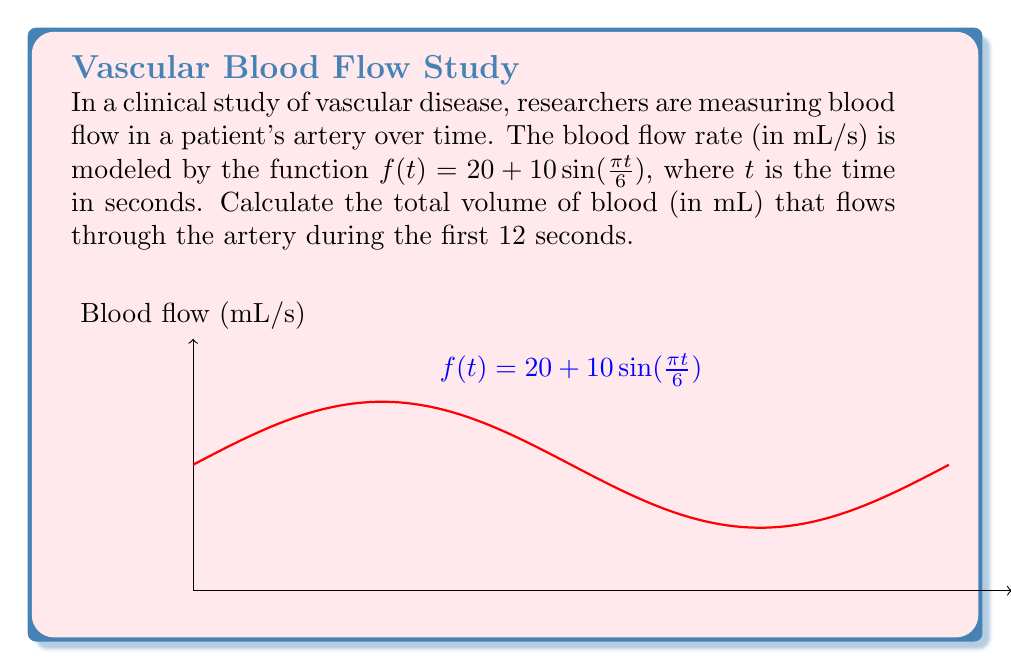Give your solution to this math problem. To find the total volume of blood that flows through the artery, we need to calculate the area under the curve of the blood flow rate function over the given time interval. This can be done using definite integration.

1) The function representing blood flow rate is:
   $f(t) = 20 + 10\sin(\frac{\pi t}{6})$

2) We need to integrate this function from $t=0$ to $t=12$:
   $\int_0^{12} (20 + 10\sin(\frac{\pi t}{6})) dt$

3) Let's separate the integral:
   $\int_0^{12} 20 dt + \int_0^{12} 10\sin(\frac{\pi t}{6}) dt$

4) Evaluate the first part:
   $20t|_0^{12} = 20 \cdot 12 - 20 \cdot 0 = 240$

5) For the second part, we use the substitution method:
   Let $u = \frac{\pi t}{6}$, then $du = \frac{\pi}{6}dt$ or $dt = \frac{6}{\pi}du$
   When $t=0$, $u=0$; when $t=12$, $u=2\pi$

6) Rewrite the second integral:
   $10 \cdot \frac{6}{\pi} \int_0^{2\pi} \sin(u) du$

7) Evaluate:
   $\frac{60}{\pi} [-\cos(u)]_0^{2\pi} = \frac{60}{\pi} [-\cos(2\pi) + \cos(0)] = 0$

8) Sum the results:
   Total volume = $240 + 0 = 240$ mL
Answer: 240 mL 